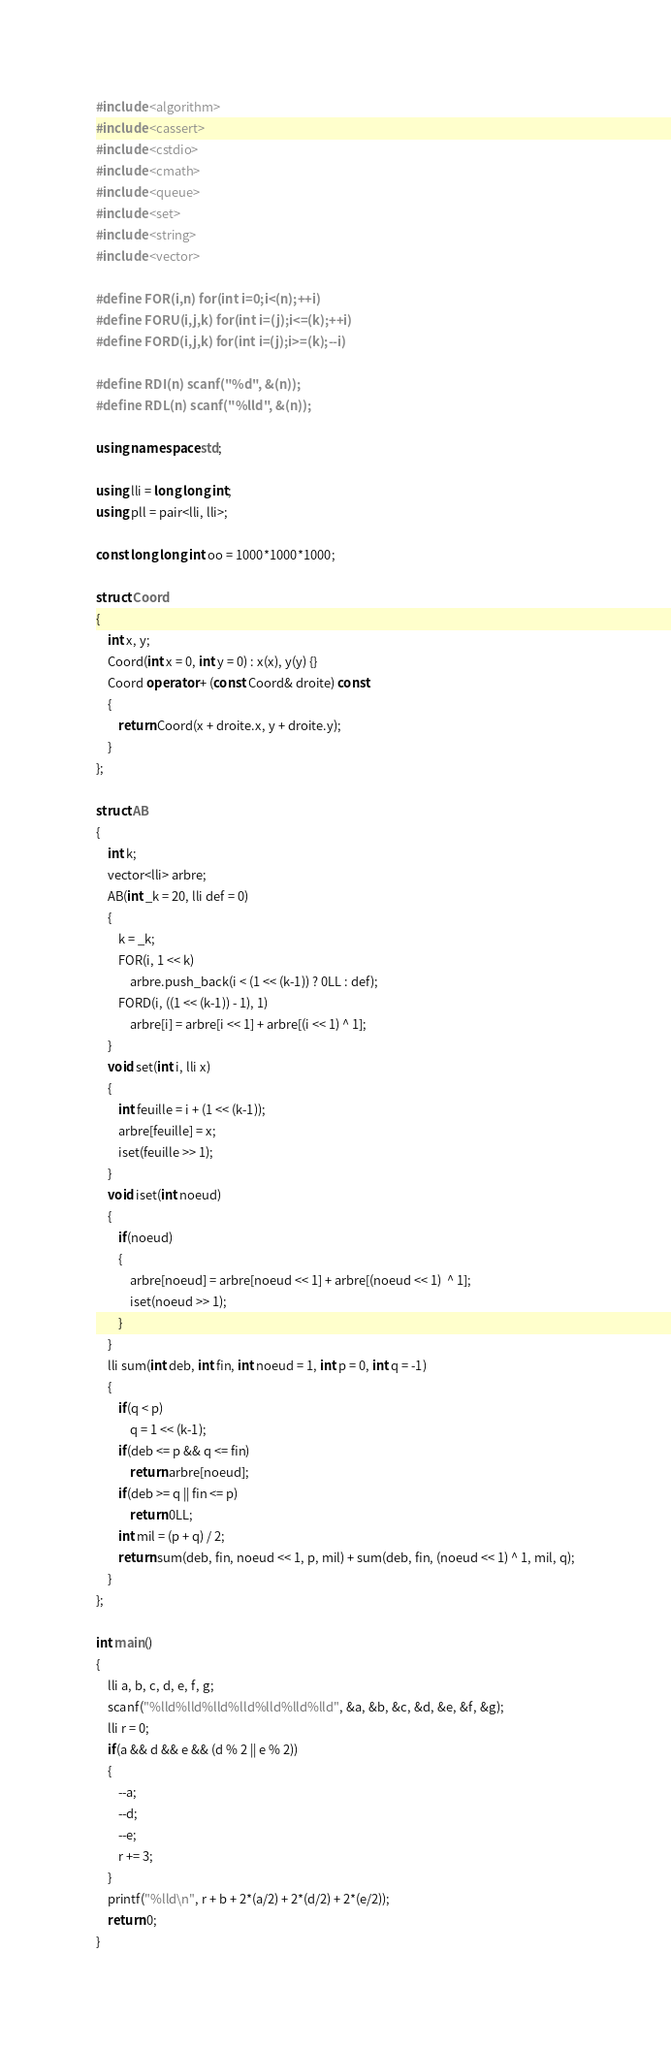<code> <loc_0><loc_0><loc_500><loc_500><_C++_>#include <algorithm>
#include <cassert>
#include <cstdio>
#include <cmath>
#include <queue>
#include <set>
#include <string>
#include <vector>

#define FOR(i,n) for(int i=0;i<(n);++i)
#define FORU(i,j,k) for(int i=(j);i<=(k);++i)
#define FORD(i,j,k) for(int i=(j);i>=(k);--i)

#define RDI(n) scanf("%d", &(n));
#define RDL(n) scanf("%lld", &(n));

using namespace std;

using lli = long long int;
using pll = pair<lli, lli>;

const long long int oo = 1000*1000*1000;

struct Coord
{
	int x, y;
	Coord(int x = 0, int y = 0) : x(x), y(y) {}
	Coord operator + (const Coord& droite) const
	{
		return Coord(x + droite.x, y + droite.y);
	}
};

struct AB
{
	int k;
	vector<lli> arbre;
	AB(int _k = 20, lli def = 0)
	{
		k = _k;
		FOR(i, 1 << k)
			arbre.push_back(i < (1 << (k-1)) ? 0LL : def);
		FORD(i, ((1 << (k-1)) - 1), 1)
			arbre[i] = arbre[i << 1] + arbre[(i << 1) ^ 1];
	}
	void set(int i, lli x)
	{
		int feuille = i + (1 << (k-1));
		arbre[feuille] = x;
		iset(feuille >> 1);
	}
	void iset(int noeud)
	{
		if(noeud)
		{
			arbre[noeud] = arbre[noeud << 1] + arbre[(noeud << 1)  ^ 1];
			iset(noeud >> 1);
		}
	}
	lli sum(int deb, int fin, int noeud = 1, int p = 0, int q = -1)
	{
		if(q < p)
			q = 1 << (k-1);
		if(deb <= p && q <= fin)
			return arbre[noeud];
		if(deb >= q || fin <= p)
			return 0LL;
		int mil = (p + q) / 2;
		return sum(deb, fin, noeud << 1, p, mil) + sum(deb, fin, (noeud << 1) ^ 1, mil, q);
	}
};

int main()
{
	lli a, b, c, d, e, f, g;
	scanf("%lld%lld%lld%lld%lld%lld%lld", &a, &b, &c, &d, &e, &f, &g);
	lli r = 0;
	if(a && d && e && (d % 2 || e % 2))
	{
		--a;
		--d;
		--e;
		r += 3;
	}
	printf("%lld\n", r + b + 2*(a/2) + 2*(d/2) + 2*(e/2));
	return 0;
}
</code> 